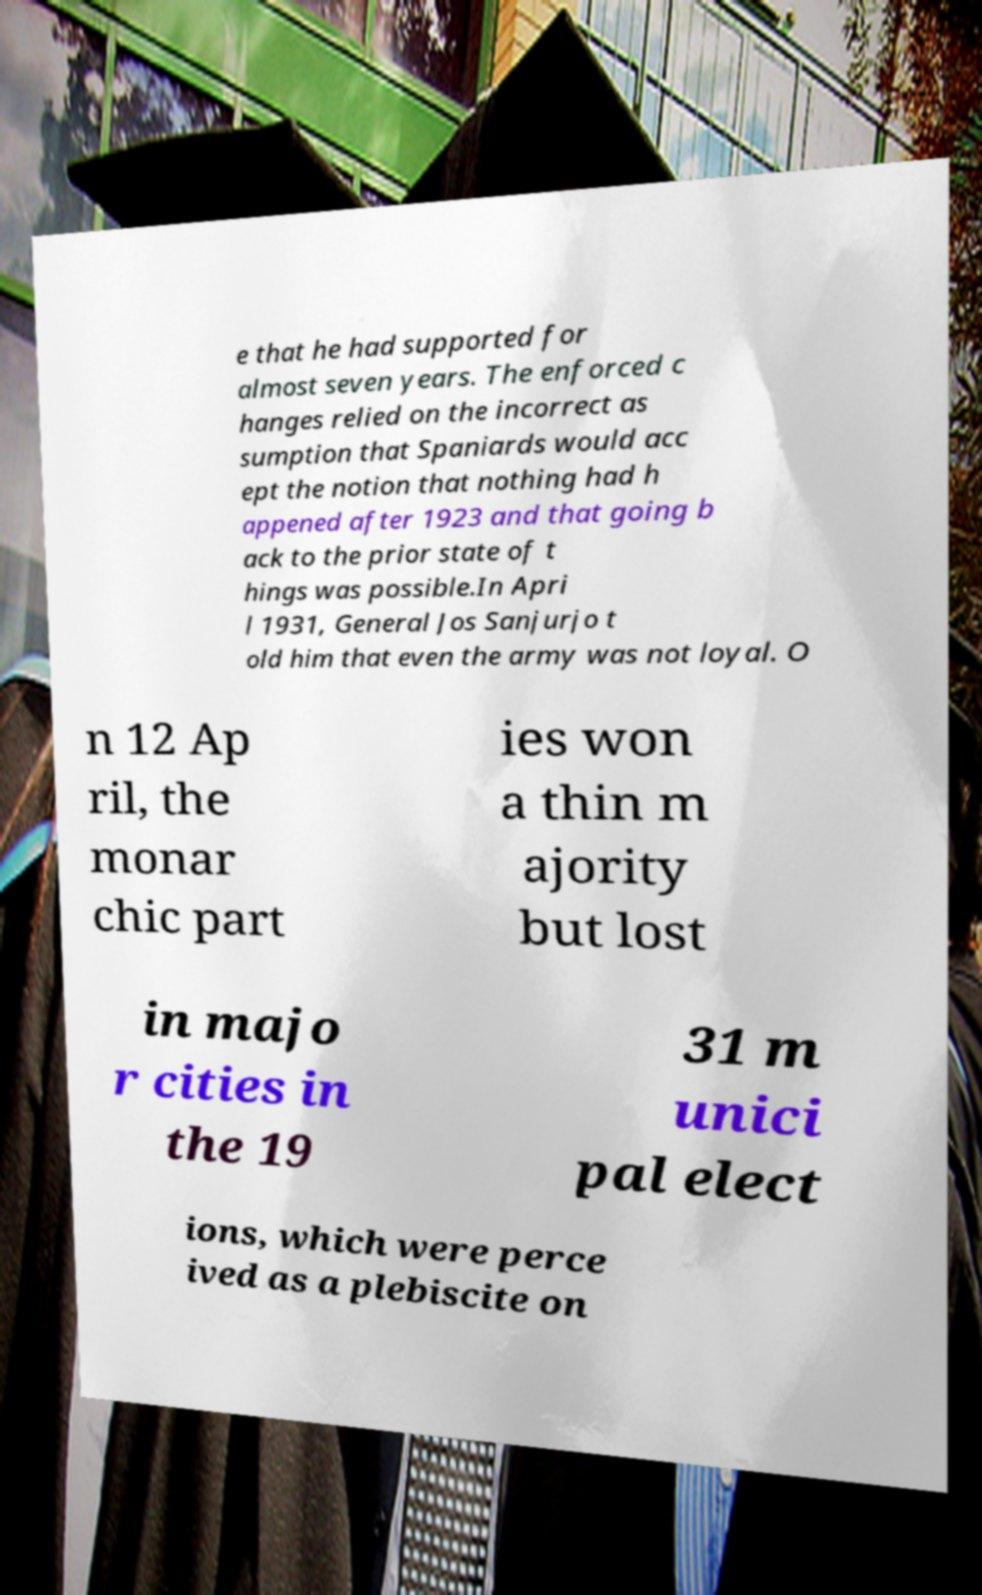Could you extract and type out the text from this image? e that he had supported for almost seven years. The enforced c hanges relied on the incorrect as sumption that Spaniards would acc ept the notion that nothing had h appened after 1923 and that going b ack to the prior state of t hings was possible.In Apri l 1931, General Jos Sanjurjo t old him that even the army was not loyal. O n 12 Ap ril, the monar chic part ies won a thin m ajority but lost in majo r cities in the 19 31 m unici pal elect ions, which were perce ived as a plebiscite on 